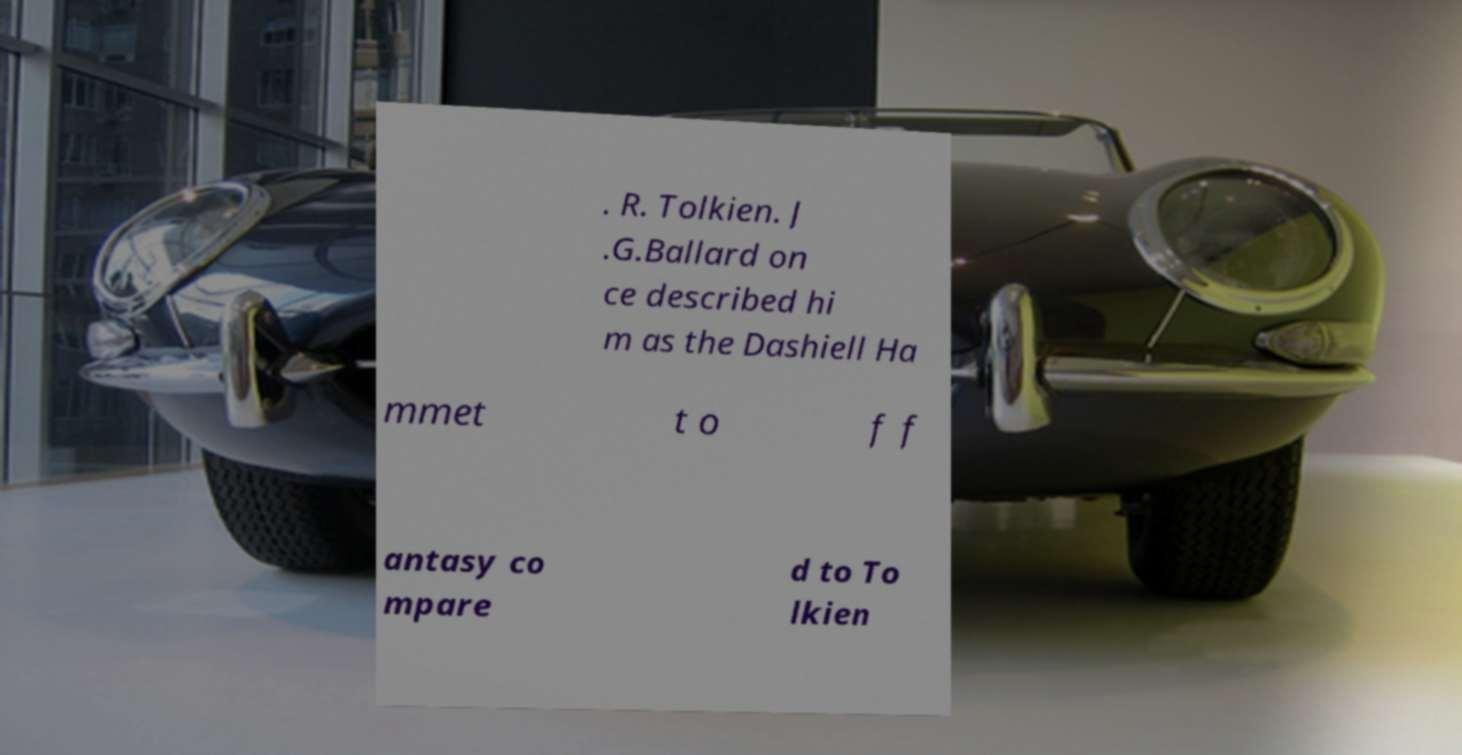Could you extract and type out the text from this image? . R. Tolkien. J .G.Ballard on ce described hi m as the Dashiell Ha mmet t o f f antasy co mpare d to To lkien 